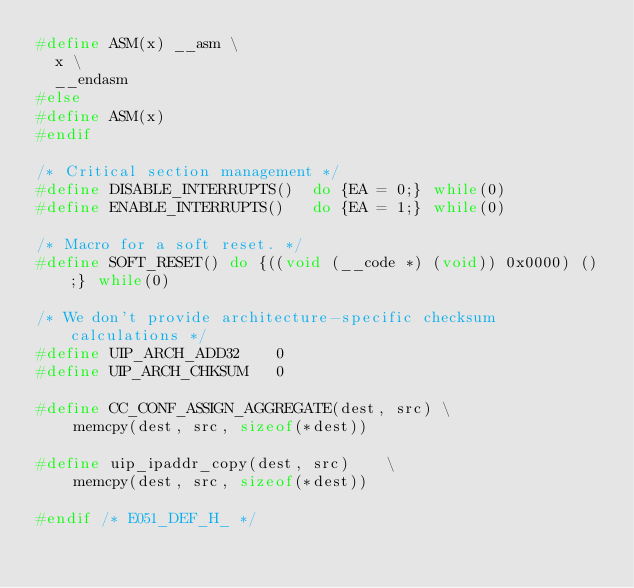Convert code to text. <code><loc_0><loc_0><loc_500><loc_500><_C_>#define ASM(x) __asm \
  x \
  __endasm
#else
#define ASM(x)
#endif

/* Critical section management */
#define DISABLE_INTERRUPTS()  do {EA = 0;} while(0)
#define ENABLE_INTERRUPTS()   do {EA = 1;} while(0)

/* Macro for a soft reset. */
#define SOFT_RESET() do {((void (__code *) (void)) 0x0000) ();} while(0)

/* We don't provide architecture-specific checksum calculations */
#define UIP_ARCH_ADD32    0
#define UIP_ARCH_CHKSUM	  0

#define CC_CONF_ASSIGN_AGGREGATE(dest, src)	\
    memcpy(dest, src, sizeof(*dest))

#define uip_ipaddr_copy(dest, src)		\
    memcpy(dest, src, sizeof(*dest))

#endif /* E051_DEF_H_ */
</code> 